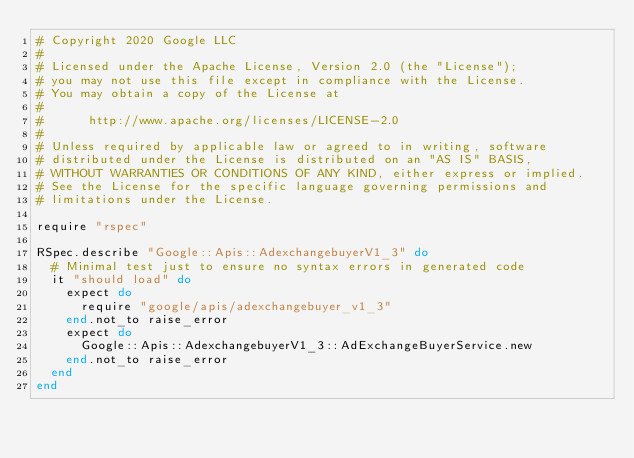<code> <loc_0><loc_0><loc_500><loc_500><_Ruby_># Copyright 2020 Google LLC
#
# Licensed under the Apache License, Version 2.0 (the "License");
# you may not use this file except in compliance with the License.
# You may obtain a copy of the License at
#
#      http://www.apache.org/licenses/LICENSE-2.0
#
# Unless required by applicable law or agreed to in writing, software
# distributed under the License is distributed on an "AS IS" BASIS,
# WITHOUT WARRANTIES OR CONDITIONS OF ANY KIND, either express or implied.
# See the License for the specific language governing permissions and
# limitations under the License.

require "rspec"

RSpec.describe "Google::Apis::AdexchangebuyerV1_3" do
  # Minimal test just to ensure no syntax errors in generated code
  it "should load" do
    expect do
      require "google/apis/adexchangebuyer_v1_3"
    end.not_to raise_error
    expect do
      Google::Apis::AdexchangebuyerV1_3::AdExchangeBuyerService.new
    end.not_to raise_error
  end
end
</code> 